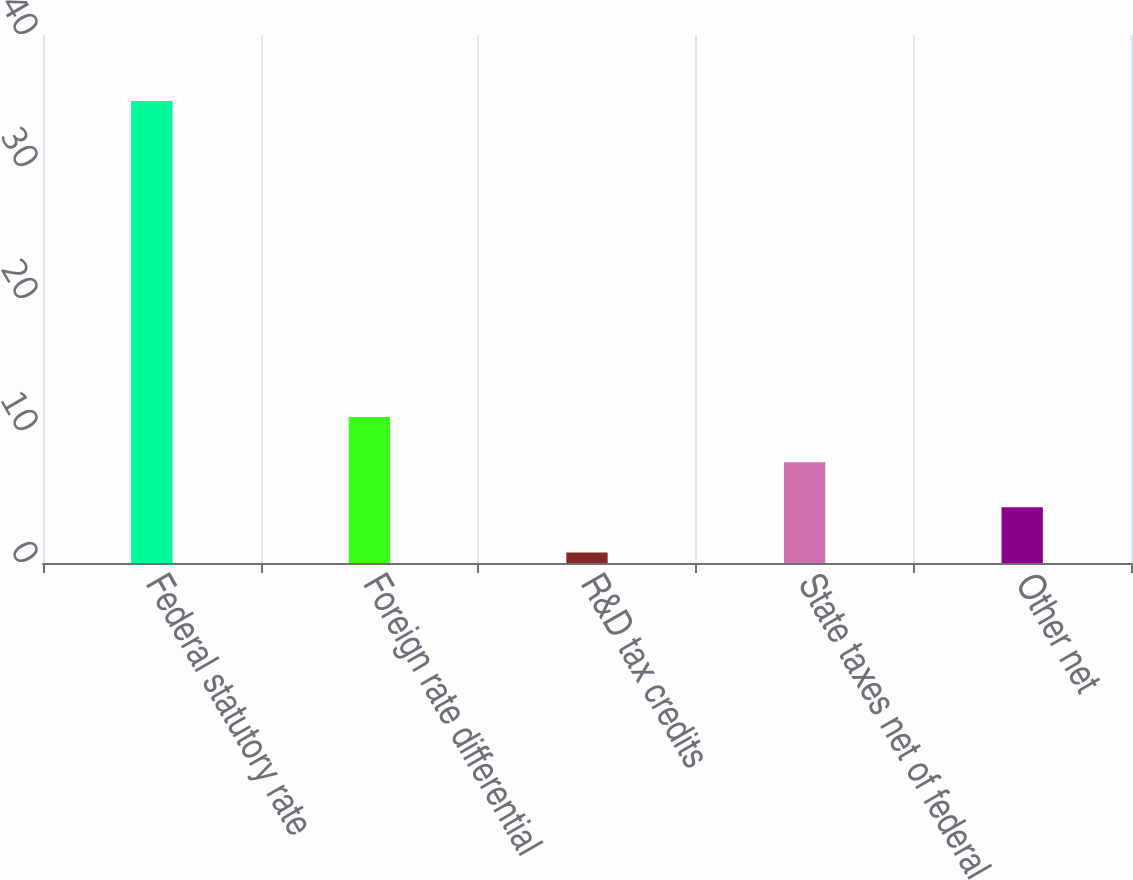Convert chart to OTSL. <chart><loc_0><loc_0><loc_500><loc_500><bar_chart><fcel>Federal statutory rate<fcel>Foreign rate differential<fcel>R&D tax credits<fcel>State taxes net of federal<fcel>Other net<nl><fcel>35<fcel>11.06<fcel>0.8<fcel>7.64<fcel>4.22<nl></chart> 